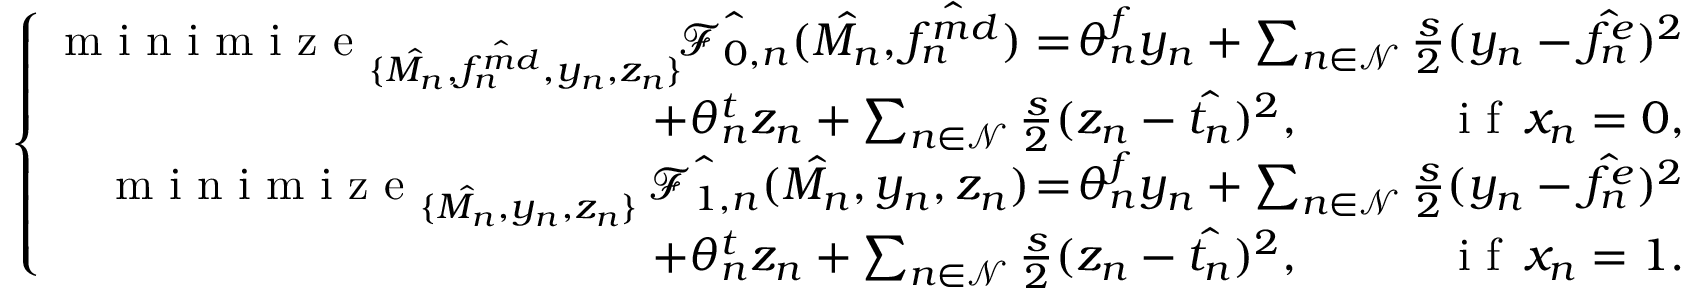Convert formula to latex. <formula><loc_0><loc_0><loc_500><loc_500>\begin{array} { r } { \, \left \{ { \begin{array} { r } { \, \min i m i z e _ { \{ \hat { M _ { n } } , \hat { f _ { n } ^ { m d } } , y _ { n } , z _ { n } \} } \, \hat { \mathcal { F } _ { 0 , n } } ( \hat { M _ { n } } , \hat { f _ { n } ^ { m d } } ) = \, \theta _ { n } ^ { f } y _ { n } + \sum _ { n \in \mathcal { N } } \frac { s } { 2 } ( y _ { n } - \hat { f _ { n } ^ { e } } ) ^ { 2 } } \\ { + \theta _ { n } ^ { t } z _ { n } + \sum _ { n \in \mathcal { N } } \frac { s } { 2 } ( z _ { n } - \hat { t _ { n } } ) ^ { 2 } , \quad i f x _ { n } = 0 , } \\ { \, \min i m i z e _ { \{ \hat { M _ { n } } , y _ { n } , z _ { n } \} } \hat { \mathcal { F } _ { 1 , n } } ( \hat { M _ { n } } , y _ { n } , z _ { n } ) \, = \, \theta _ { n } ^ { f } y _ { n } + \sum _ { n \in \mathcal { N } } \frac { s } { 2 } ( y _ { n } - \hat { f _ { n } ^ { e } } ) ^ { 2 } } \\ { + \theta _ { n } ^ { t } z _ { n } + \sum _ { n \in \mathcal { N } } \frac { s } { 2 } ( z _ { n } - \hat { t _ { n } } ) ^ { 2 } , \quad i f x _ { n } = 1 . } \end{array} } } \end{array}</formula> 